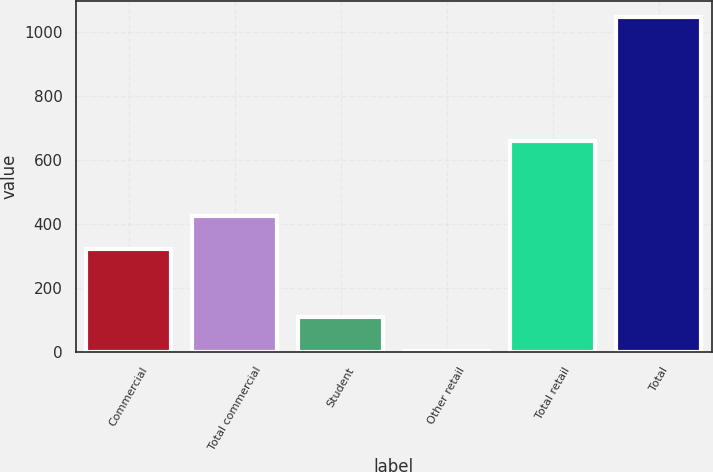Convert chart to OTSL. <chart><loc_0><loc_0><loc_500><loc_500><bar_chart><fcel>Commercial<fcel>Total commercial<fcel>Student<fcel>Other retail<fcel>Total retail<fcel>Total<nl><fcel>322<fcel>426.1<fcel>108.1<fcel>4<fcel>658<fcel>1045<nl></chart> 